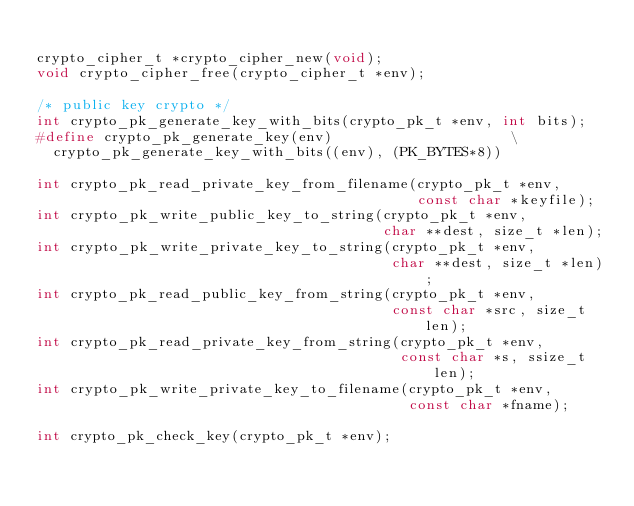Convert code to text. <code><loc_0><loc_0><loc_500><loc_500><_C_>
crypto_cipher_t *crypto_cipher_new(void);
void crypto_cipher_free(crypto_cipher_t *env);

/* public key crypto */
int crypto_pk_generate_key_with_bits(crypto_pk_t *env, int bits);
#define crypto_pk_generate_key(env)                     \
  crypto_pk_generate_key_with_bits((env), (PK_BYTES*8))

int crypto_pk_read_private_key_from_filename(crypto_pk_t *env,
                                             const char *keyfile);
int crypto_pk_write_public_key_to_string(crypto_pk_t *env,
                                         char **dest, size_t *len);
int crypto_pk_write_private_key_to_string(crypto_pk_t *env,
                                          char **dest, size_t *len);
int crypto_pk_read_public_key_from_string(crypto_pk_t *env,
                                          const char *src, size_t len);
int crypto_pk_read_private_key_from_string(crypto_pk_t *env,
                                           const char *s, ssize_t len);
int crypto_pk_write_private_key_to_filename(crypto_pk_t *env,
                                            const char *fname);

int crypto_pk_check_key(crypto_pk_t *env);</code> 